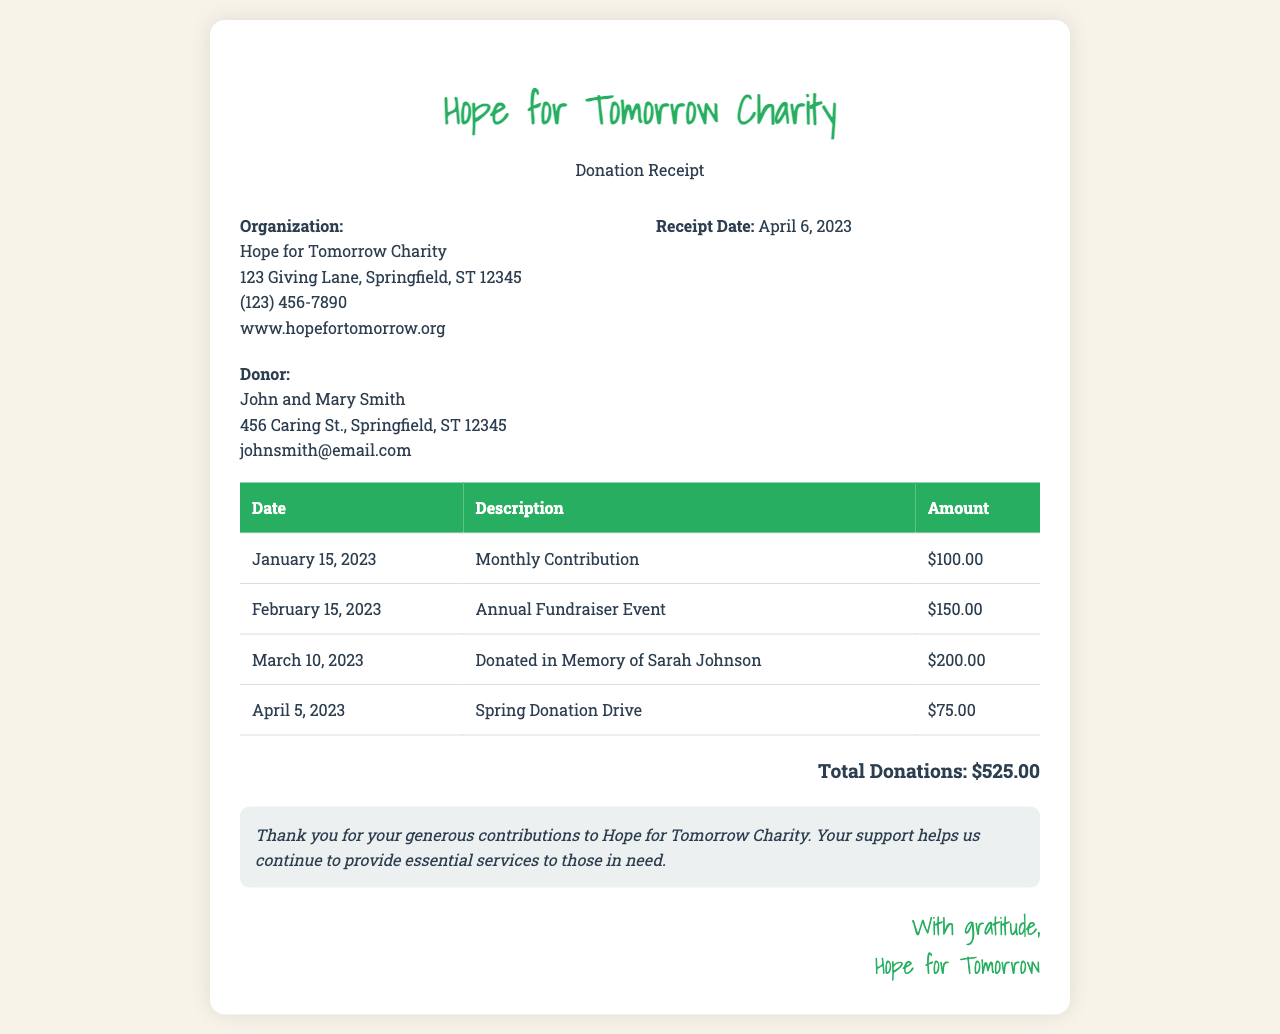What is the organization name? The name of the organization is located at the top of the receipt.
Answer: Hope for Tomorrow Charity What is the receipt date? The receipt date is specified within the organization information section.
Answer: April 6, 2023 Who is the donor? The donor's information is listed in the donor info section of the receipt.
Answer: John and Mary Smith What is the amount for the Annual Fundraiser Event? This amount can be found in the table under the description for the event.
Answer: $150.00 What is the total donations amount? The total donations is the sum of all individual contributions listed in the document.
Answer: $525.00 What date corresponds to the donation made in memory of someone? This date is provided in the table and refers to a specific donation.
Answer: March 10, 2023 How many total donations are listed? To find this, we count the number of donation entries in the table.
Answer: 4 What is the address of the organization? The address is part of the organization information section in the document.
Answer: 123 Giving Lane, Springfield, ST 12345 What is the email of the donor? The donor's email address is found in the donor info section.
Answer: johnsmith@email.com 